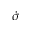Convert formula to latex. <formula><loc_0><loc_0><loc_500><loc_500>\dot { \sigma }</formula> 